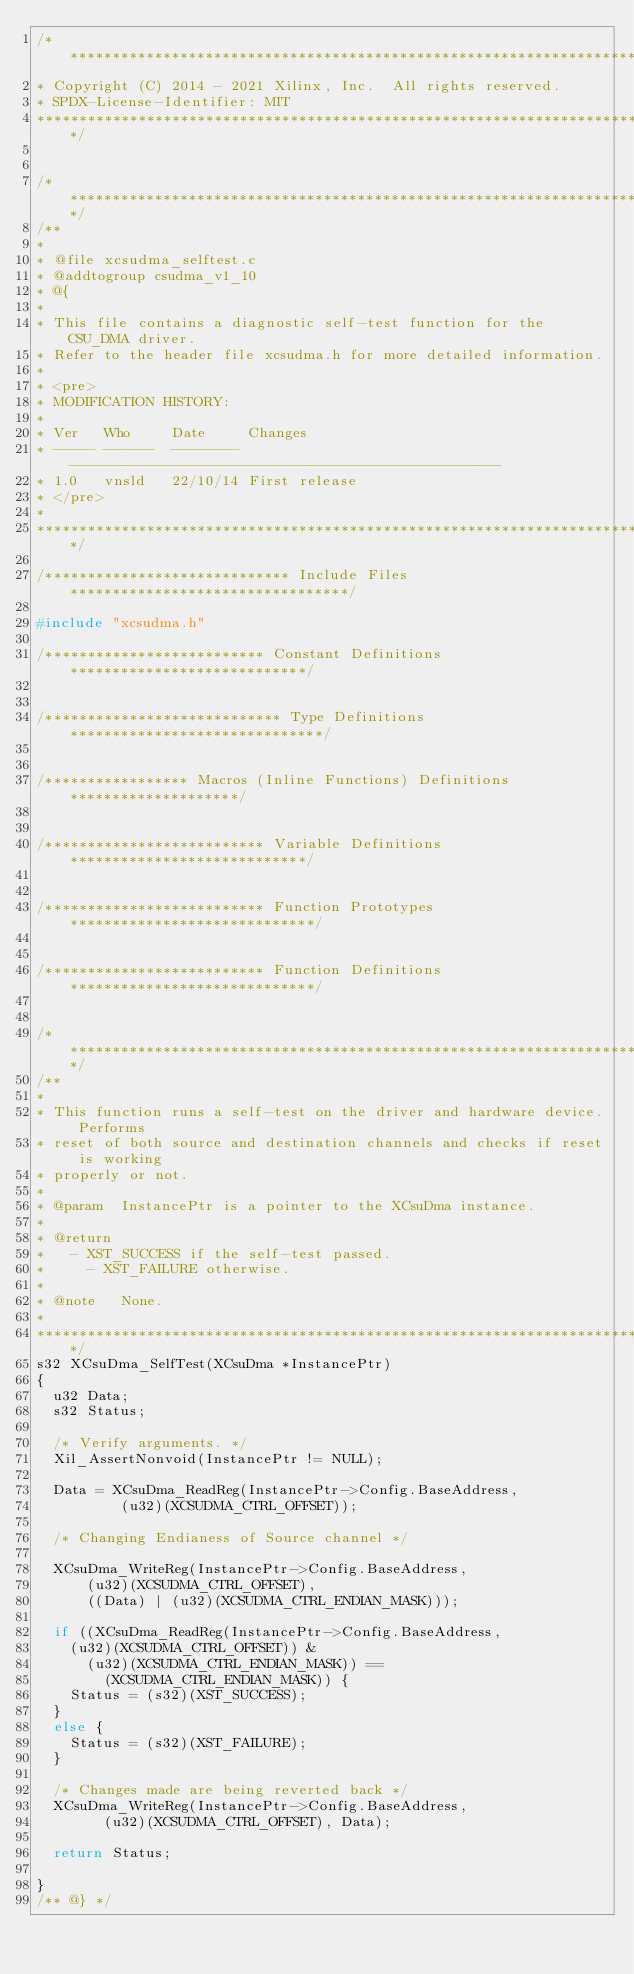Convert code to text. <code><loc_0><loc_0><loc_500><loc_500><_C_>/******************************************************************************
* Copyright (C) 2014 - 2021 Xilinx, Inc.  All rights reserved.
* SPDX-License-Identifier: MIT
******************************************************************************/


/*****************************************************************************/
/**
*
* @file xcsudma_selftest.c
* @addtogroup csudma_v1_10
* @{
*
* This file contains a diagnostic self-test function for the CSU_DMA driver.
* Refer to the header file xcsudma.h for more detailed information.
*
* <pre>
* MODIFICATION HISTORY:
*
* Ver   Who     Date     Changes
* ----- ------  -------- ---------------------------------------------------
* 1.0   vnsld   22/10/14 First release
* </pre>
*
******************************************************************************/

/***************************** Include Files *********************************/

#include "xcsudma.h"

/************************** Constant Definitions ****************************/


/**************************** Type Definitions ******************************/


/***************** Macros (Inline Functions) Definitions ********************/


/************************** Variable Definitions ****************************/


/************************** Function Prototypes *****************************/


/************************** Function Definitions *****************************/


/*****************************************************************************/
/**
*
* This function runs a self-test on the driver and hardware device. Performs
* reset of both source and destination channels and checks if reset is working
* properly or not.
*
* @param	InstancePtr is a pointer to the XCsuDma instance.
*
* @return
*		- XST_SUCCESS if the self-test passed.
* 		- XST_FAILURE otherwise.
*
* @note		None.
*
******************************************************************************/
s32 XCsuDma_SelfTest(XCsuDma *InstancePtr)
{
	u32 Data;
	s32 Status;

	/* Verify arguments. */
	Xil_AssertNonvoid(InstancePtr != NULL);

	Data = XCsuDma_ReadReg(InstancePtr->Config.BaseAddress,
					(u32)(XCSUDMA_CTRL_OFFSET));

	/* Changing Endianess of Source channel */

	XCsuDma_WriteReg(InstancePtr->Config.BaseAddress,
			(u32)(XCSUDMA_CTRL_OFFSET),
			((Data) | (u32)(XCSUDMA_CTRL_ENDIAN_MASK)));

	if ((XCsuDma_ReadReg(InstancePtr->Config.BaseAddress,
		(u32)(XCSUDMA_CTRL_OFFSET)) &
			(u32)(XCSUDMA_CTRL_ENDIAN_MASK)) ==
				(XCSUDMA_CTRL_ENDIAN_MASK)) {
		Status = (s32)(XST_SUCCESS);
	}
	else {
		Status = (s32)(XST_FAILURE);
	}

	/* Changes made are being reverted back */
	XCsuDma_WriteReg(InstancePtr->Config.BaseAddress,
				(u32)(XCSUDMA_CTRL_OFFSET), Data);

	return Status;

}
/** @} */
</code> 